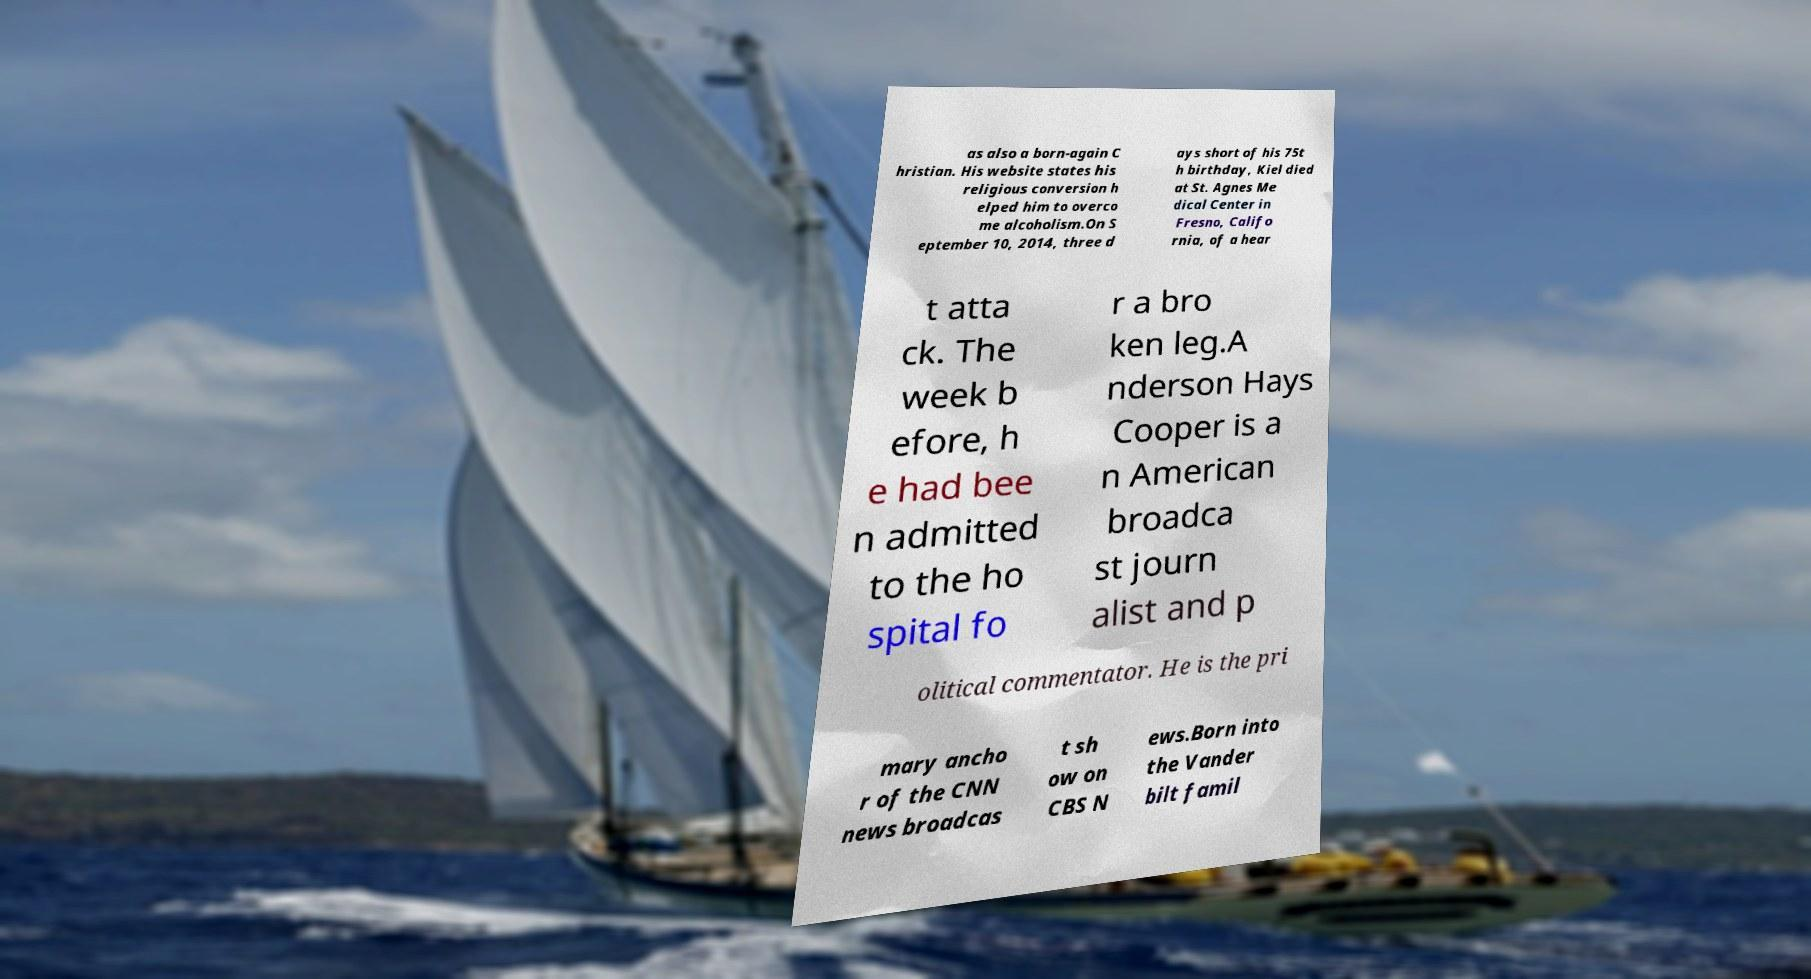For documentation purposes, I need the text within this image transcribed. Could you provide that? as also a born-again C hristian. His website states his religious conversion h elped him to overco me alcoholism.On S eptember 10, 2014, three d ays short of his 75t h birthday, Kiel died at St. Agnes Me dical Center in Fresno, Califo rnia, of a hear t atta ck. The week b efore, h e had bee n admitted to the ho spital fo r a bro ken leg.A nderson Hays Cooper is a n American broadca st journ alist and p olitical commentator. He is the pri mary ancho r of the CNN news broadcas t sh ow on CBS N ews.Born into the Vander bilt famil 